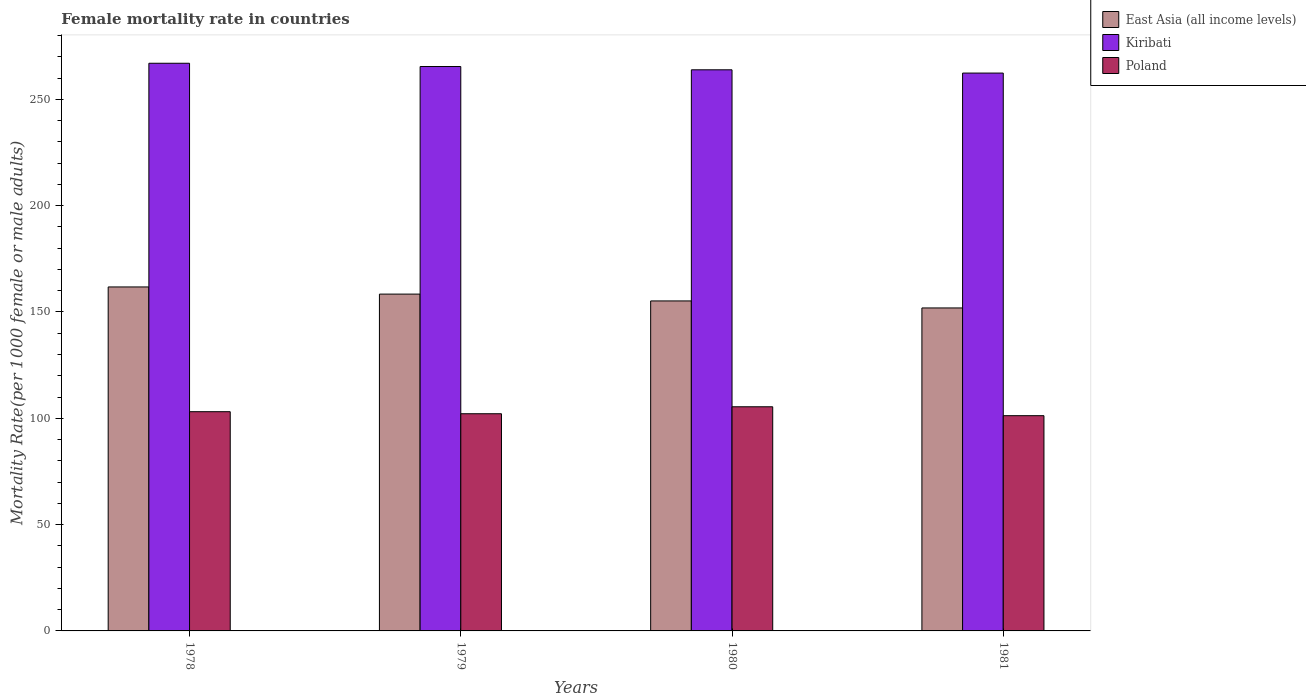How many groups of bars are there?
Provide a succinct answer. 4. Are the number of bars per tick equal to the number of legend labels?
Provide a succinct answer. Yes. Are the number of bars on each tick of the X-axis equal?
Your answer should be compact. Yes. What is the female mortality rate in East Asia (all income levels) in 1980?
Keep it short and to the point. 155.19. Across all years, what is the maximum female mortality rate in Poland?
Offer a very short reply. 105.41. Across all years, what is the minimum female mortality rate in Kiribati?
Make the answer very short. 262.33. In which year was the female mortality rate in East Asia (all income levels) maximum?
Give a very brief answer. 1978. What is the total female mortality rate in East Asia (all income levels) in the graph?
Offer a very short reply. 627.22. What is the difference between the female mortality rate in Poland in 1980 and that in 1981?
Make the answer very short. 4.19. What is the difference between the female mortality rate in Poland in 1981 and the female mortality rate in Kiribati in 1980?
Offer a very short reply. -162.65. What is the average female mortality rate in East Asia (all income levels) per year?
Make the answer very short. 156.8. In the year 1980, what is the difference between the female mortality rate in Kiribati and female mortality rate in East Asia (all income levels)?
Make the answer very short. 108.69. What is the ratio of the female mortality rate in Kiribati in 1978 to that in 1980?
Offer a very short reply. 1.01. Is the female mortality rate in Poland in 1979 less than that in 1980?
Provide a short and direct response. Yes. Is the difference between the female mortality rate in Kiribati in 1979 and 1980 greater than the difference between the female mortality rate in East Asia (all income levels) in 1979 and 1980?
Keep it short and to the point. No. What is the difference between the highest and the second highest female mortality rate in East Asia (all income levels)?
Offer a very short reply. 3.37. What is the difference between the highest and the lowest female mortality rate in Kiribati?
Make the answer very short. 4.62. In how many years, is the female mortality rate in Kiribati greater than the average female mortality rate in Kiribati taken over all years?
Provide a short and direct response. 2. What does the 2nd bar from the right in 1980 represents?
Offer a very short reply. Kiribati. How many bars are there?
Make the answer very short. 12. Are all the bars in the graph horizontal?
Ensure brevity in your answer.  No. What is the difference between two consecutive major ticks on the Y-axis?
Make the answer very short. 50. Are the values on the major ticks of Y-axis written in scientific E-notation?
Provide a succinct answer. No. Does the graph contain grids?
Your answer should be very brief. No. Where does the legend appear in the graph?
Make the answer very short. Top right. How many legend labels are there?
Keep it short and to the point. 3. What is the title of the graph?
Keep it short and to the point. Female mortality rate in countries. What is the label or title of the X-axis?
Offer a terse response. Years. What is the label or title of the Y-axis?
Provide a succinct answer. Mortality Rate(per 1000 female or male adults). What is the Mortality Rate(per 1000 female or male adults) in East Asia (all income levels) in 1978?
Your answer should be compact. 161.76. What is the Mortality Rate(per 1000 female or male adults) in Kiribati in 1978?
Keep it short and to the point. 266.95. What is the Mortality Rate(per 1000 female or male adults) in Poland in 1978?
Provide a succinct answer. 103.09. What is the Mortality Rate(per 1000 female or male adults) of East Asia (all income levels) in 1979?
Offer a very short reply. 158.39. What is the Mortality Rate(per 1000 female or male adults) in Kiribati in 1979?
Provide a short and direct response. 265.41. What is the Mortality Rate(per 1000 female or male adults) in Poland in 1979?
Give a very brief answer. 102.13. What is the Mortality Rate(per 1000 female or male adults) of East Asia (all income levels) in 1980?
Your answer should be very brief. 155.19. What is the Mortality Rate(per 1000 female or male adults) of Kiribati in 1980?
Offer a terse response. 263.87. What is the Mortality Rate(per 1000 female or male adults) in Poland in 1980?
Provide a short and direct response. 105.41. What is the Mortality Rate(per 1000 female or male adults) of East Asia (all income levels) in 1981?
Give a very brief answer. 151.88. What is the Mortality Rate(per 1000 female or male adults) in Kiribati in 1981?
Keep it short and to the point. 262.33. What is the Mortality Rate(per 1000 female or male adults) of Poland in 1981?
Offer a very short reply. 101.22. Across all years, what is the maximum Mortality Rate(per 1000 female or male adults) of East Asia (all income levels)?
Make the answer very short. 161.76. Across all years, what is the maximum Mortality Rate(per 1000 female or male adults) in Kiribati?
Give a very brief answer. 266.95. Across all years, what is the maximum Mortality Rate(per 1000 female or male adults) in Poland?
Make the answer very short. 105.41. Across all years, what is the minimum Mortality Rate(per 1000 female or male adults) of East Asia (all income levels)?
Offer a terse response. 151.88. Across all years, what is the minimum Mortality Rate(per 1000 female or male adults) in Kiribati?
Your response must be concise. 262.33. Across all years, what is the minimum Mortality Rate(per 1000 female or male adults) of Poland?
Give a very brief answer. 101.22. What is the total Mortality Rate(per 1000 female or male adults) in East Asia (all income levels) in the graph?
Ensure brevity in your answer.  627.22. What is the total Mortality Rate(per 1000 female or male adults) in Kiribati in the graph?
Offer a terse response. 1058.57. What is the total Mortality Rate(per 1000 female or male adults) of Poland in the graph?
Make the answer very short. 411.85. What is the difference between the Mortality Rate(per 1000 female or male adults) in East Asia (all income levels) in 1978 and that in 1979?
Your answer should be compact. 3.37. What is the difference between the Mortality Rate(per 1000 female or male adults) of Kiribati in 1978 and that in 1979?
Your answer should be very brief. 1.54. What is the difference between the Mortality Rate(per 1000 female or male adults) of East Asia (all income levels) in 1978 and that in 1980?
Give a very brief answer. 6.57. What is the difference between the Mortality Rate(per 1000 female or male adults) in Kiribati in 1978 and that in 1980?
Provide a short and direct response. 3.08. What is the difference between the Mortality Rate(per 1000 female or male adults) of Poland in 1978 and that in 1980?
Your answer should be compact. -2.31. What is the difference between the Mortality Rate(per 1000 female or male adults) of East Asia (all income levels) in 1978 and that in 1981?
Ensure brevity in your answer.  9.88. What is the difference between the Mortality Rate(per 1000 female or male adults) of Kiribati in 1978 and that in 1981?
Give a very brief answer. 4.62. What is the difference between the Mortality Rate(per 1000 female or male adults) in Poland in 1978 and that in 1981?
Your answer should be very brief. 1.87. What is the difference between the Mortality Rate(per 1000 female or male adults) of East Asia (all income levels) in 1979 and that in 1980?
Make the answer very short. 3.21. What is the difference between the Mortality Rate(per 1000 female or male adults) of Kiribati in 1979 and that in 1980?
Your answer should be very brief. 1.54. What is the difference between the Mortality Rate(per 1000 female or male adults) in Poland in 1979 and that in 1980?
Ensure brevity in your answer.  -3.27. What is the difference between the Mortality Rate(per 1000 female or male adults) in East Asia (all income levels) in 1979 and that in 1981?
Provide a short and direct response. 6.51. What is the difference between the Mortality Rate(per 1000 female or male adults) of Kiribati in 1979 and that in 1981?
Give a very brief answer. 3.08. What is the difference between the Mortality Rate(per 1000 female or male adults) in Poland in 1979 and that in 1981?
Make the answer very short. 0.91. What is the difference between the Mortality Rate(per 1000 female or male adults) of East Asia (all income levels) in 1980 and that in 1981?
Offer a terse response. 3.3. What is the difference between the Mortality Rate(per 1000 female or male adults) of Kiribati in 1980 and that in 1981?
Make the answer very short. 1.54. What is the difference between the Mortality Rate(per 1000 female or male adults) in Poland in 1980 and that in 1981?
Provide a succinct answer. 4.19. What is the difference between the Mortality Rate(per 1000 female or male adults) in East Asia (all income levels) in 1978 and the Mortality Rate(per 1000 female or male adults) in Kiribati in 1979?
Your response must be concise. -103.65. What is the difference between the Mortality Rate(per 1000 female or male adults) of East Asia (all income levels) in 1978 and the Mortality Rate(per 1000 female or male adults) of Poland in 1979?
Provide a short and direct response. 59.63. What is the difference between the Mortality Rate(per 1000 female or male adults) of Kiribati in 1978 and the Mortality Rate(per 1000 female or male adults) of Poland in 1979?
Ensure brevity in your answer.  164.82. What is the difference between the Mortality Rate(per 1000 female or male adults) in East Asia (all income levels) in 1978 and the Mortality Rate(per 1000 female or male adults) in Kiribati in 1980?
Provide a short and direct response. -102.11. What is the difference between the Mortality Rate(per 1000 female or male adults) in East Asia (all income levels) in 1978 and the Mortality Rate(per 1000 female or male adults) in Poland in 1980?
Offer a terse response. 56.35. What is the difference between the Mortality Rate(per 1000 female or male adults) of Kiribati in 1978 and the Mortality Rate(per 1000 female or male adults) of Poland in 1980?
Keep it short and to the point. 161.55. What is the difference between the Mortality Rate(per 1000 female or male adults) of East Asia (all income levels) in 1978 and the Mortality Rate(per 1000 female or male adults) of Kiribati in 1981?
Your answer should be compact. -100.58. What is the difference between the Mortality Rate(per 1000 female or male adults) of East Asia (all income levels) in 1978 and the Mortality Rate(per 1000 female or male adults) of Poland in 1981?
Keep it short and to the point. 60.54. What is the difference between the Mortality Rate(per 1000 female or male adults) of Kiribati in 1978 and the Mortality Rate(per 1000 female or male adults) of Poland in 1981?
Offer a terse response. 165.73. What is the difference between the Mortality Rate(per 1000 female or male adults) in East Asia (all income levels) in 1979 and the Mortality Rate(per 1000 female or male adults) in Kiribati in 1980?
Provide a succinct answer. -105.48. What is the difference between the Mortality Rate(per 1000 female or male adults) of East Asia (all income levels) in 1979 and the Mortality Rate(per 1000 female or male adults) of Poland in 1980?
Your answer should be very brief. 52.99. What is the difference between the Mortality Rate(per 1000 female or male adults) in Kiribati in 1979 and the Mortality Rate(per 1000 female or male adults) in Poland in 1980?
Provide a succinct answer. 160.01. What is the difference between the Mortality Rate(per 1000 female or male adults) of East Asia (all income levels) in 1979 and the Mortality Rate(per 1000 female or male adults) of Kiribati in 1981?
Provide a short and direct response. -103.94. What is the difference between the Mortality Rate(per 1000 female or male adults) of East Asia (all income levels) in 1979 and the Mortality Rate(per 1000 female or male adults) of Poland in 1981?
Make the answer very short. 57.17. What is the difference between the Mortality Rate(per 1000 female or male adults) of Kiribati in 1979 and the Mortality Rate(per 1000 female or male adults) of Poland in 1981?
Provide a succinct answer. 164.19. What is the difference between the Mortality Rate(per 1000 female or male adults) of East Asia (all income levels) in 1980 and the Mortality Rate(per 1000 female or male adults) of Kiribati in 1981?
Your answer should be very brief. -107.15. What is the difference between the Mortality Rate(per 1000 female or male adults) in East Asia (all income levels) in 1980 and the Mortality Rate(per 1000 female or male adults) in Poland in 1981?
Give a very brief answer. 53.97. What is the difference between the Mortality Rate(per 1000 female or male adults) in Kiribati in 1980 and the Mortality Rate(per 1000 female or male adults) in Poland in 1981?
Offer a very short reply. 162.65. What is the average Mortality Rate(per 1000 female or male adults) in East Asia (all income levels) per year?
Ensure brevity in your answer.  156.8. What is the average Mortality Rate(per 1000 female or male adults) in Kiribati per year?
Provide a succinct answer. 264.64. What is the average Mortality Rate(per 1000 female or male adults) of Poland per year?
Your answer should be very brief. 102.96. In the year 1978, what is the difference between the Mortality Rate(per 1000 female or male adults) in East Asia (all income levels) and Mortality Rate(per 1000 female or male adults) in Kiribati?
Your answer should be very brief. -105.19. In the year 1978, what is the difference between the Mortality Rate(per 1000 female or male adults) in East Asia (all income levels) and Mortality Rate(per 1000 female or male adults) in Poland?
Your response must be concise. 58.67. In the year 1978, what is the difference between the Mortality Rate(per 1000 female or male adults) of Kiribati and Mortality Rate(per 1000 female or male adults) of Poland?
Your answer should be very brief. 163.86. In the year 1979, what is the difference between the Mortality Rate(per 1000 female or male adults) in East Asia (all income levels) and Mortality Rate(per 1000 female or male adults) in Kiribati?
Make the answer very short. -107.02. In the year 1979, what is the difference between the Mortality Rate(per 1000 female or male adults) of East Asia (all income levels) and Mortality Rate(per 1000 female or male adults) of Poland?
Make the answer very short. 56.26. In the year 1979, what is the difference between the Mortality Rate(per 1000 female or male adults) in Kiribati and Mortality Rate(per 1000 female or male adults) in Poland?
Your answer should be compact. 163.28. In the year 1980, what is the difference between the Mortality Rate(per 1000 female or male adults) of East Asia (all income levels) and Mortality Rate(per 1000 female or male adults) of Kiribati?
Provide a succinct answer. -108.69. In the year 1980, what is the difference between the Mortality Rate(per 1000 female or male adults) of East Asia (all income levels) and Mortality Rate(per 1000 female or male adults) of Poland?
Provide a short and direct response. 49.78. In the year 1980, what is the difference between the Mortality Rate(per 1000 female or male adults) in Kiribati and Mortality Rate(per 1000 female or male adults) in Poland?
Ensure brevity in your answer.  158.47. In the year 1981, what is the difference between the Mortality Rate(per 1000 female or male adults) in East Asia (all income levels) and Mortality Rate(per 1000 female or male adults) in Kiribati?
Offer a very short reply. -110.45. In the year 1981, what is the difference between the Mortality Rate(per 1000 female or male adults) in East Asia (all income levels) and Mortality Rate(per 1000 female or male adults) in Poland?
Your answer should be very brief. 50.66. In the year 1981, what is the difference between the Mortality Rate(per 1000 female or male adults) of Kiribati and Mortality Rate(per 1000 female or male adults) of Poland?
Give a very brief answer. 161.12. What is the ratio of the Mortality Rate(per 1000 female or male adults) of East Asia (all income levels) in 1978 to that in 1979?
Offer a terse response. 1.02. What is the ratio of the Mortality Rate(per 1000 female or male adults) in Kiribati in 1978 to that in 1979?
Ensure brevity in your answer.  1.01. What is the ratio of the Mortality Rate(per 1000 female or male adults) of Poland in 1978 to that in 1979?
Your answer should be very brief. 1.01. What is the ratio of the Mortality Rate(per 1000 female or male adults) in East Asia (all income levels) in 1978 to that in 1980?
Provide a short and direct response. 1.04. What is the ratio of the Mortality Rate(per 1000 female or male adults) of Kiribati in 1978 to that in 1980?
Keep it short and to the point. 1.01. What is the ratio of the Mortality Rate(per 1000 female or male adults) of Poland in 1978 to that in 1980?
Your response must be concise. 0.98. What is the ratio of the Mortality Rate(per 1000 female or male adults) in East Asia (all income levels) in 1978 to that in 1981?
Your answer should be very brief. 1.06. What is the ratio of the Mortality Rate(per 1000 female or male adults) of Kiribati in 1978 to that in 1981?
Offer a terse response. 1.02. What is the ratio of the Mortality Rate(per 1000 female or male adults) in Poland in 1978 to that in 1981?
Your answer should be very brief. 1.02. What is the ratio of the Mortality Rate(per 1000 female or male adults) in East Asia (all income levels) in 1979 to that in 1980?
Give a very brief answer. 1.02. What is the ratio of the Mortality Rate(per 1000 female or male adults) of Poland in 1979 to that in 1980?
Your answer should be compact. 0.97. What is the ratio of the Mortality Rate(per 1000 female or male adults) of East Asia (all income levels) in 1979 to that in 1981?
Ensure brevity in your answer.  1.04. What is the ratio of the Mortality Rate(per 1000 female or male adults) in Kiribati in 1979 to that in 1981?
Ensure brevity in your answer.  1.01. What is the ratio of the Mortality Rate(per 1000 female or male adults) in East Asia (all income levels) in 1980 to that in 1981?
Provide a short and direct response. 1.02. What is the ratio of the Mortality Rate(per 1000 female or male adults) in Kiribati in 1980 to that in 1981?
Offer a terse response. 1.01. What is the ratio of the Mortality Rate(per 1000 female or male adults) of Poland in 1980 to that in 1981?
Offer a terse response. 1.04. What is the difference between the highest and the second highest Mortality Rate(per 1000 female or male adults) in East Asia (all income levels)?
Your answer should be compact. 3.37. What is the difference between the highest and the second highest Mortality Rate(per 1000 female or male adults) of Kiribati?
Your answer should be very brief. 1.54. What is the difference between the highest and the second highest Mortality Rate(per 1000 female or male adults) in Poland?
Keep it short and to the point. 2.31. What is the difference between the highest and the lowest Mortality Rate(per 1000 female or male adults) of East Asia (all income levels)?
Keep it short and to the point. 9.88. What is the difference between the highest and the lowest Mortality Rate(per 1000 female or male adults) in Kiribati?
Your answer should be compact. 4.62. What is the difference between the highest and the lowest Mortality Rate(per 1000 female or male adults) of Poland?
Offer a very short reply. 4.19. 